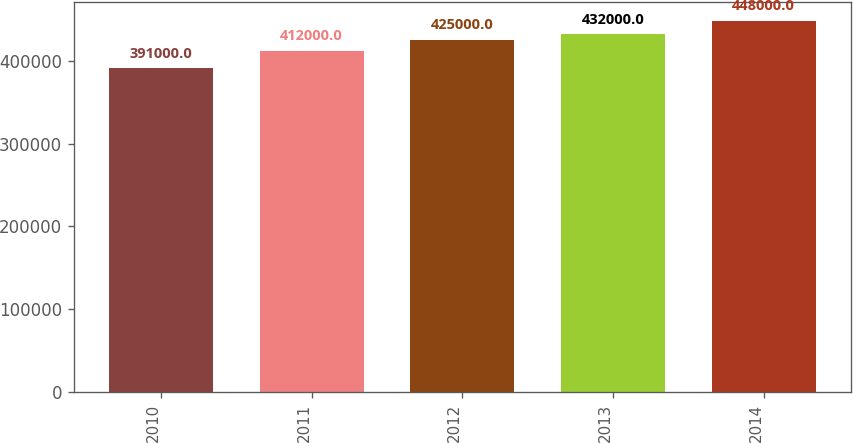<chart> <loc_0><loc_0><loc_500><loc_500><bar_chart><fcel>2010<fcel>2011<fcel>2012<fcel>2013<fcel>2014<nl><fcel>391000<fcel>412000<fcel>425000<fcel>432000<fcel>448000<nl></chart> 